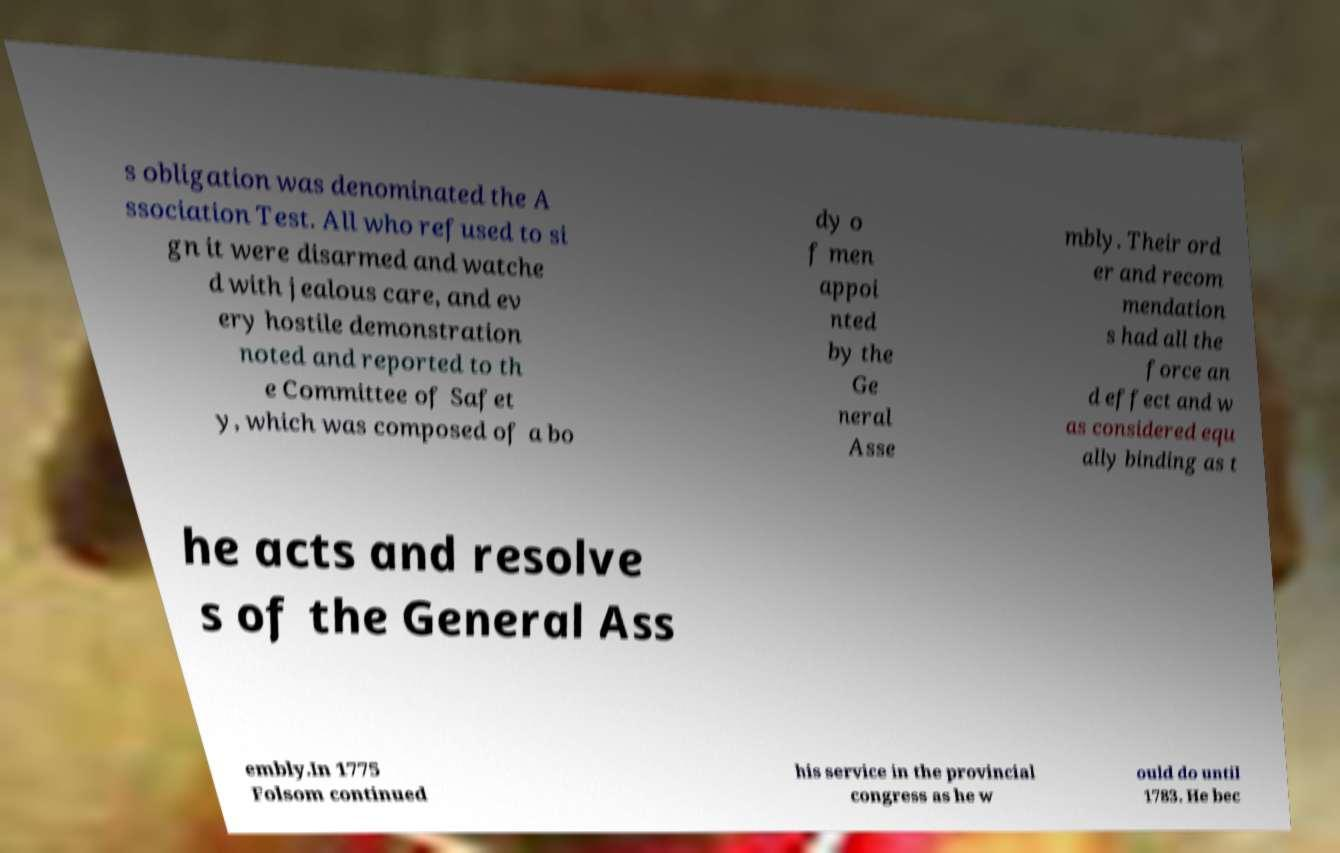Can you read and provide the text displayed in the image?This photo seems to have some interesting text. Can you extract and type it out for me? s obligation was denominated the A ssociation Test. All who refused to si gn it were disarmed and watche d with jealous care, and ev ery hostile demonstration noted and reported to th e Committee of Safet y, which was composed of a bo dy o f men appoi nted by the Ge neral Asse mbly. Their ord er and recom mendation s had all the force an d effect and w as considered equ ally binding as t he acts and resolve s of the General Ass embly.In 1775 Folsom continued his service in the provincial congress as he w ould do until 1783. He bec 